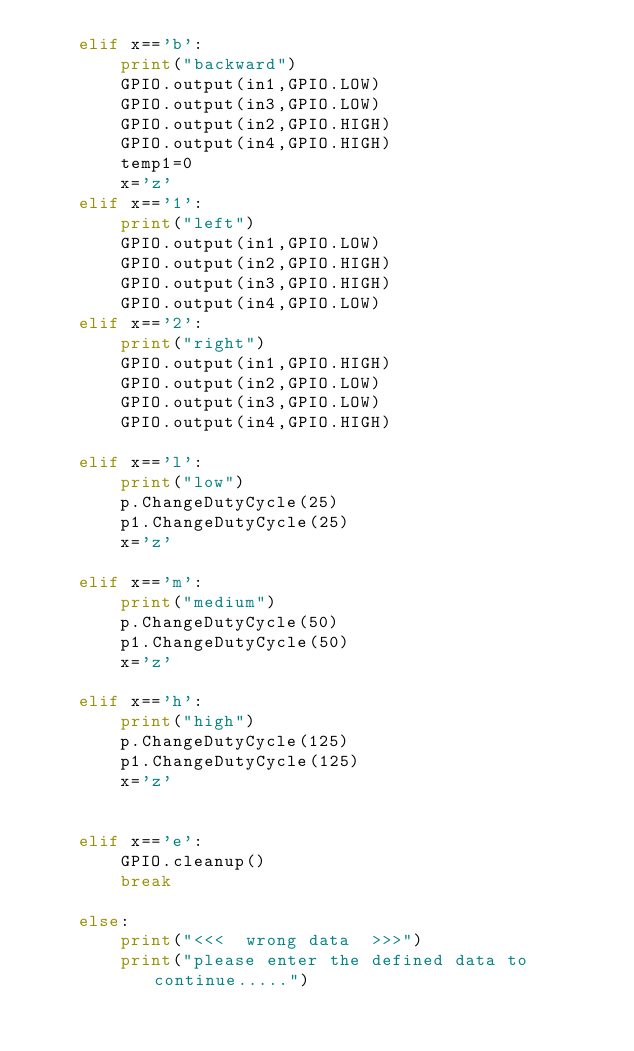<code> <loc_0><loc_0><loc_500><loc_500><_Python_>    elif x=='b':
        print("backward")
        GPIO.output(in1,GPIO.LOW)
        GPIO.output(in3,GPIO.LOW)
        GPIO.output(in2,GPIO.HIGH)
        GPIO.output(in4,GPIO.HIGH)
        temp1=0
        x='z'
    elif x=='1':
        print("left")
        GPIO.output(in1,GPIO.LOW)
        GPIO.output(in2,GPIO.HIGH)
        GPIO.output(in3,GPIO.HIGH)
        GPIO.output(in4,GPIO.LOW)
    elif x=='2':
        print("right")
        GPIO.output(in1,GPIO.HIGH)
        GPIO.output(in2,GPIO.LOW)
        GPIO.output(in3,GPIO.LOW)
        GPIO.output(in4,GPIO.HIGH)

    elif x=='l':
        print("low")
        p.ChangeDutyCycle(25)
        p1.ChangeDutyCycle(25)
        x='z'

    elif x=='m':
        print("medium")
        p.ChangeDutyCycle(50)
        p1.ChangeDutyCycle(50)
        x='z'

    elif x=='h':
        print("high")
        p.ChangeDutyCycle(125)
        p1.ChangeDutyCycle(125)
        x='z'
     
    
    elif x=='e':
        GPIO.cleanup()
        break
    
    else:
        print("<<<  wrong data  >>>")
        print("please enter the defined data to continue.....")
</code> 